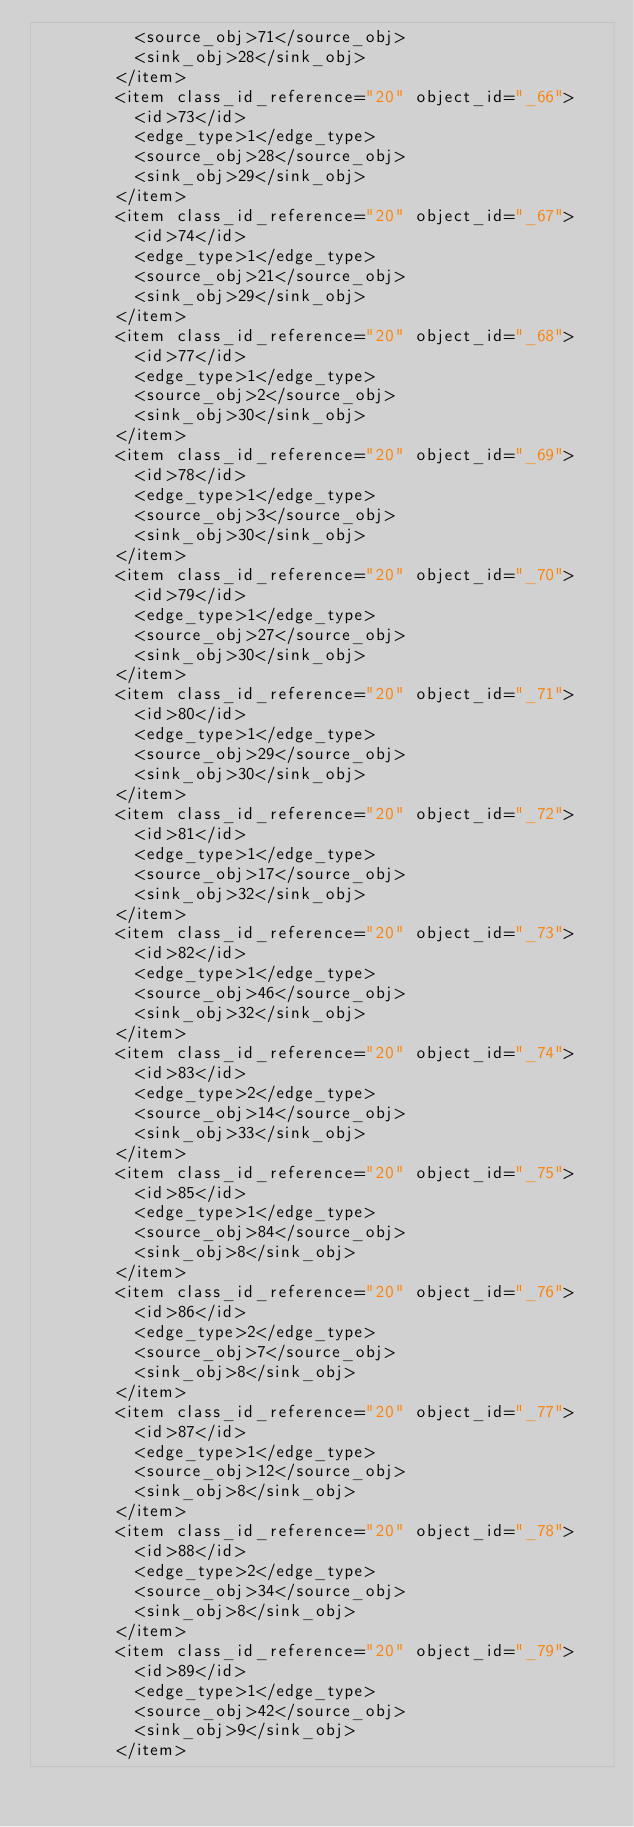Convert code to text. <code><loc_0><loc_0><loc_500><loc_500><_Ada_>          <source_obj>71</source_obj>
          <sink_obj>28</sink_obj>
        </item>
        <item class_id_reference="20" object_id="_66">
          <id>73</id>
          <edge_type>1</edge_type>
          <source_obj>28</source_obj>
          <sink_obj>29</sink_obj>
        </item>
        <item class_id_reference="20" object_id="_67">
          <id>74</id>
          <edge_type>1</edge_type>
          <source_obj>21</source_obj>
          <sink_obj>29</sink_obj>
        </item>
        <item class_id_reference="20" object_id="_68">
          <id>77</id>
          <edge_type>1</edge_type>
          <source_obj>2</source_obj>
          <sink_obj>30</sink_obj>
        </item>
        <item class_id_reference="20" object_id="_69">
          <id>78</id>
          <edge_type>1</edge_type>
          <source_obj>3</source_obj>
          <sink_obj>30</sink_obj>
        </item>
        <item class_id_reference="20" object_id="_70">
          <id>79</id>
          <edge_type>1</edge_type>
          <source_obj>27</source_obj>
          <sink_obj>30</sink_obj>
        </item>
        <item class_id_reference="20" object_id="_71">
          <id>80</id>
          <edge_type>1</edge_type>
          <source_obj>29</source_obj>
          <sink_obj>30</sink_obj>
        </item>
        <item class_id_reference="20" object_id="_72">
          <id>81</id>
          <edge_type>1</edge_type>
          <source_obj>17</source_obj>
          <sink_obj>32</sink_obj>
        </item>
        <item class_id_reference="20" object_id="_73">
          <id>82</id>
          <edge_type>1</edge_type>
          <source_obj>46</source_obj>
          <sink_obj>32</sink_obj>
        </item>
        <item class_id_reference="20" object_id="_74">
          <id>83</id>
          <edge_type>2</edge_type>
          <source_obj>14</source_obj>
          <sink_obj>33</sink_obj>
        </item>
        <item class_id_reference="20" object_id="_75">
          <id>85</id>
          <edge_type>1</edge_type>
          <source_obj>84</source_obj>
          <sink_obj>8</sink_obj>
        </item>
        <item class_id_reference="20" object_id="_76">
          <id>86</id>
          <edge_type>2</edge_type>
          <source_obj>7</source_obj>
          <sink_obj>8</sink_obj>
        </item>
        <item class_id_reference="20" object_id="_77">
          <id>87</id>
          <edge_type>1</edge_type>
          <source_obj>12</source_obj>
          <sink_obj>8</sink_obj>
        </item>
        <item class_id_reference="20" object_id="_78">
          <id>88</id>
          <edge_type>2</edge_type>
          <source_obj>34</source_obj>
          <sink_obj>8</sink_obj>
        </item>
        <item class_id_reference="20" object_id="_79">
          <id>89</id>
          <edge_type>1</edge_type>
          <source_obj>42</source_obj>
          <sink_obj>9</sink_obj>
        </item></code> 